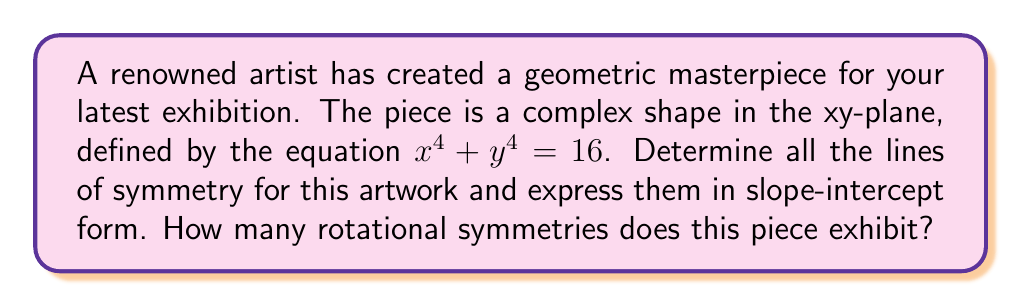Show me your answer to this math problem. Let's approach this step-by-step:

1) First, let's visualize the shape:

[asy]
import graph;
size(200);
real f(real x) {return sqrt(sqrt(16-x^4));}
draw(graph(f,-2,2));
draw(graph(-f,-2,2));
draw((-2,0)--(2,0));
draw((0,-2)--(0,2));
[/asy]

2) To find lines of symmetry, we need to consider both diagonal and axis symmetries:

   a) The equation $x^4 + y^4 = 16$ is symmetric when x and y are interchanged, suggesting diagonal symmetry.
   b) The equation remains unchanged when x or y is replaced by -x or -y, suggesting symmetry about both axes.

3) The lines of symmetry are:
   - y-axis: $x = 0$
   - x-axis: $y = 0$
   - Line $y = x$
   - Line $y = -x$

4) In slope-intercept form:
   - $y = 0$
   - $x = 0$ (vertical line, not in slope-intercept form)
   - $y = x$
   - $y = -x$

5) For rotational symmetry, we observe that the shape looks the same after every 90° rotation about the origin. This means it has 4-fold rotational symmetry (including the identity rotation).
Answer: Lines of symmetry: $y = 0$, $x = 0$, $y = x$, $y = -x$. 4 rotational symmetries. 